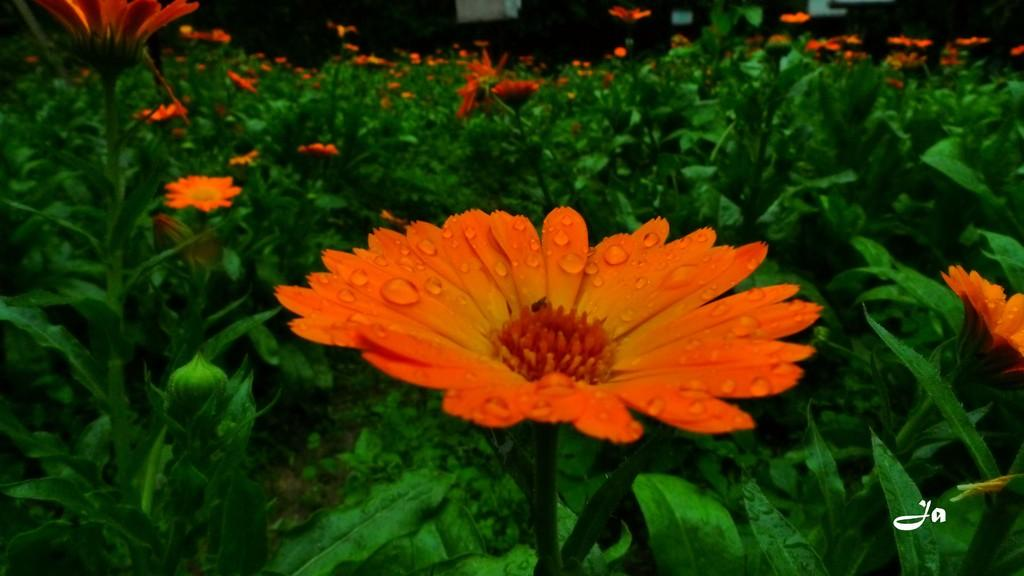What type of living organisms can be seen in the image? There are flowers in the image. What color are the flowers? The flowers are orange in color. What color are the plants that the flowers are growing on? The plants are green in color. What type of pipe is visible in the image? There is no pipe present in the image. What feelings of regret can be observed in the image? There are no feelings of regret depicted in the image, as it features flowers and plants. 